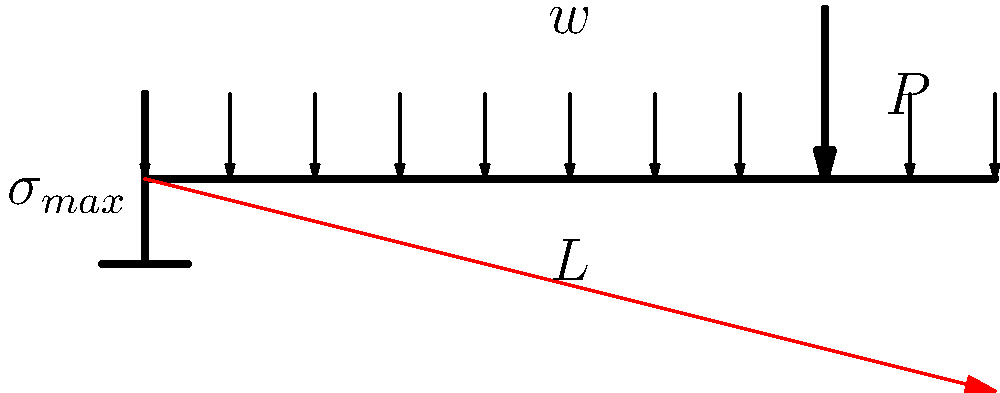As a startup founder focused on innovative solutions, you're developing a new structural analysis tool. Consider a cantilever beam of length $L$ subjected to a uniformly distributed load $w$ and a point load $P$ at a distance $0.8L$ from the fixed end. How does the stress distribution along the beam change, and what factors should your software consider to accurately model this scenario for various materials and load conditions? To accurately model the stress distribution in a cantilever beam, we need to consider several factors:

1. Beam theory: The analysis is based on Euler-Bernoulli beam theory, which assumes that plane sections remain plane and perpendicular to the neutral axis during bending.

2. Superposition principle: The total stress can be calculated by summing the effects of the distributed load and the point load separately.

3. Bending moment equation:
   For a cantilever beam with a distributed load $w$ and a point load $P$:
   $$M(x) = \frac{wL^2}{2} - \frac{wx^2}{2} + P(L-0.8L) - P(x-0.8L)H(x-0.8L)$$
   where $H$ is the Heaviside step function.

4. Stress-moment relationship:
   $$\sigma_{max}(x) = \frac{M(x)y}{I}$$
   where $y$ is the distance from the neutral axis to the extreme fiber, and $I$ is the moment of inertia.

5. Material properties: The elastic modulus $E$ affects the beam's deformation but not the stress distribution directly. However, it's crucial for calculating deflections and ensuring the material remains in the elastic region.

6. Cross-sectional geometry: The moment of inertia $I$ depends on the beam's cross-sectional shape and dimensions, affecting the stress magnitude.

7. Shear stress: While often negligible for slender beams, shear stress should be considered for short beams or near the fixed end.

8. Saint-Venant's principle: Stress concentration near the fixed end and load application points should be accounted for in detailed analysis.

The stress distribution will be maximum at the fixed end (as shown in the diagram) and decrease along the length of the beam. The point load will cause a discontinuity in the rate of change of the stress at $0.8L$.

To create an accurate software model, you should:
- Implement the bending moment equation
- Allow for variable cross-sections and material properties
- Include options for different load types and combinations
- Consider non-linear effects for large deflections
- Provide visualization tools for stress and deflection
Answer: Stress is maximum at the fixed end, decreases non-linearly along the beam, with a discontinuity at 0.8L due to the point load. Key factors: beam theory, superposition, material properties, cross-sectional geometry, and load distribution. 